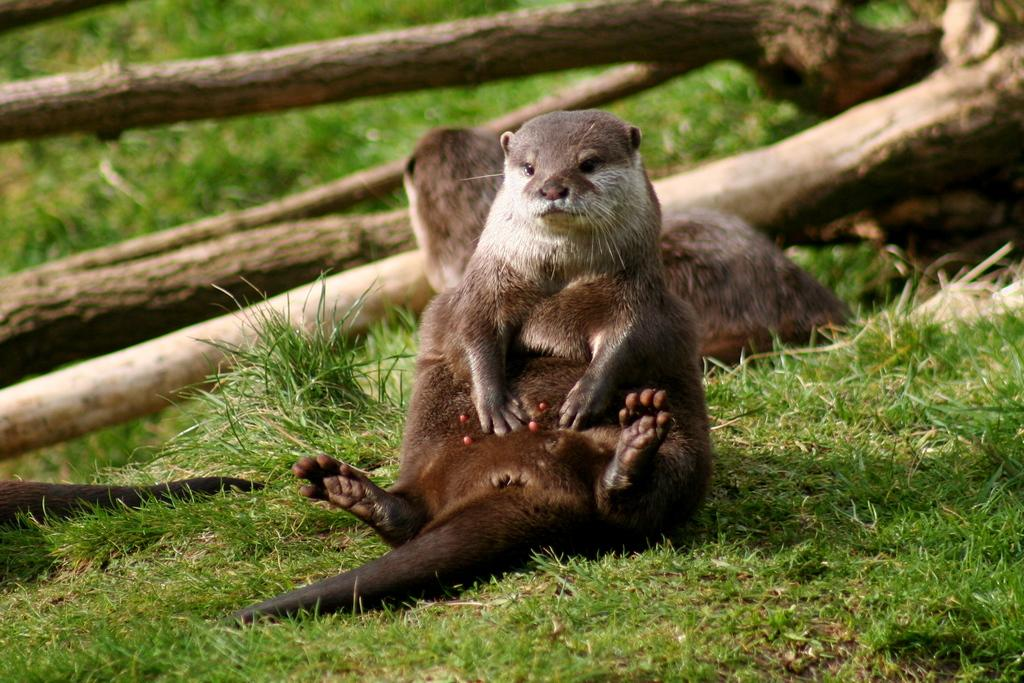What animals are present in the image? There are otters in the image. What are the otters doing in the image? The otters are laying on the grass. What can be seen in the background of the image? There are logs in the background of the image. What type of suit is the otter wearing in the image? There is no suit present in the image; the otters are animals and do not wear clothing. How many legs does the otter have in the image? Otters have four legs, but this question is not relevant to the image as it focuses on a physical attribute rather than the observable elements in the image. 